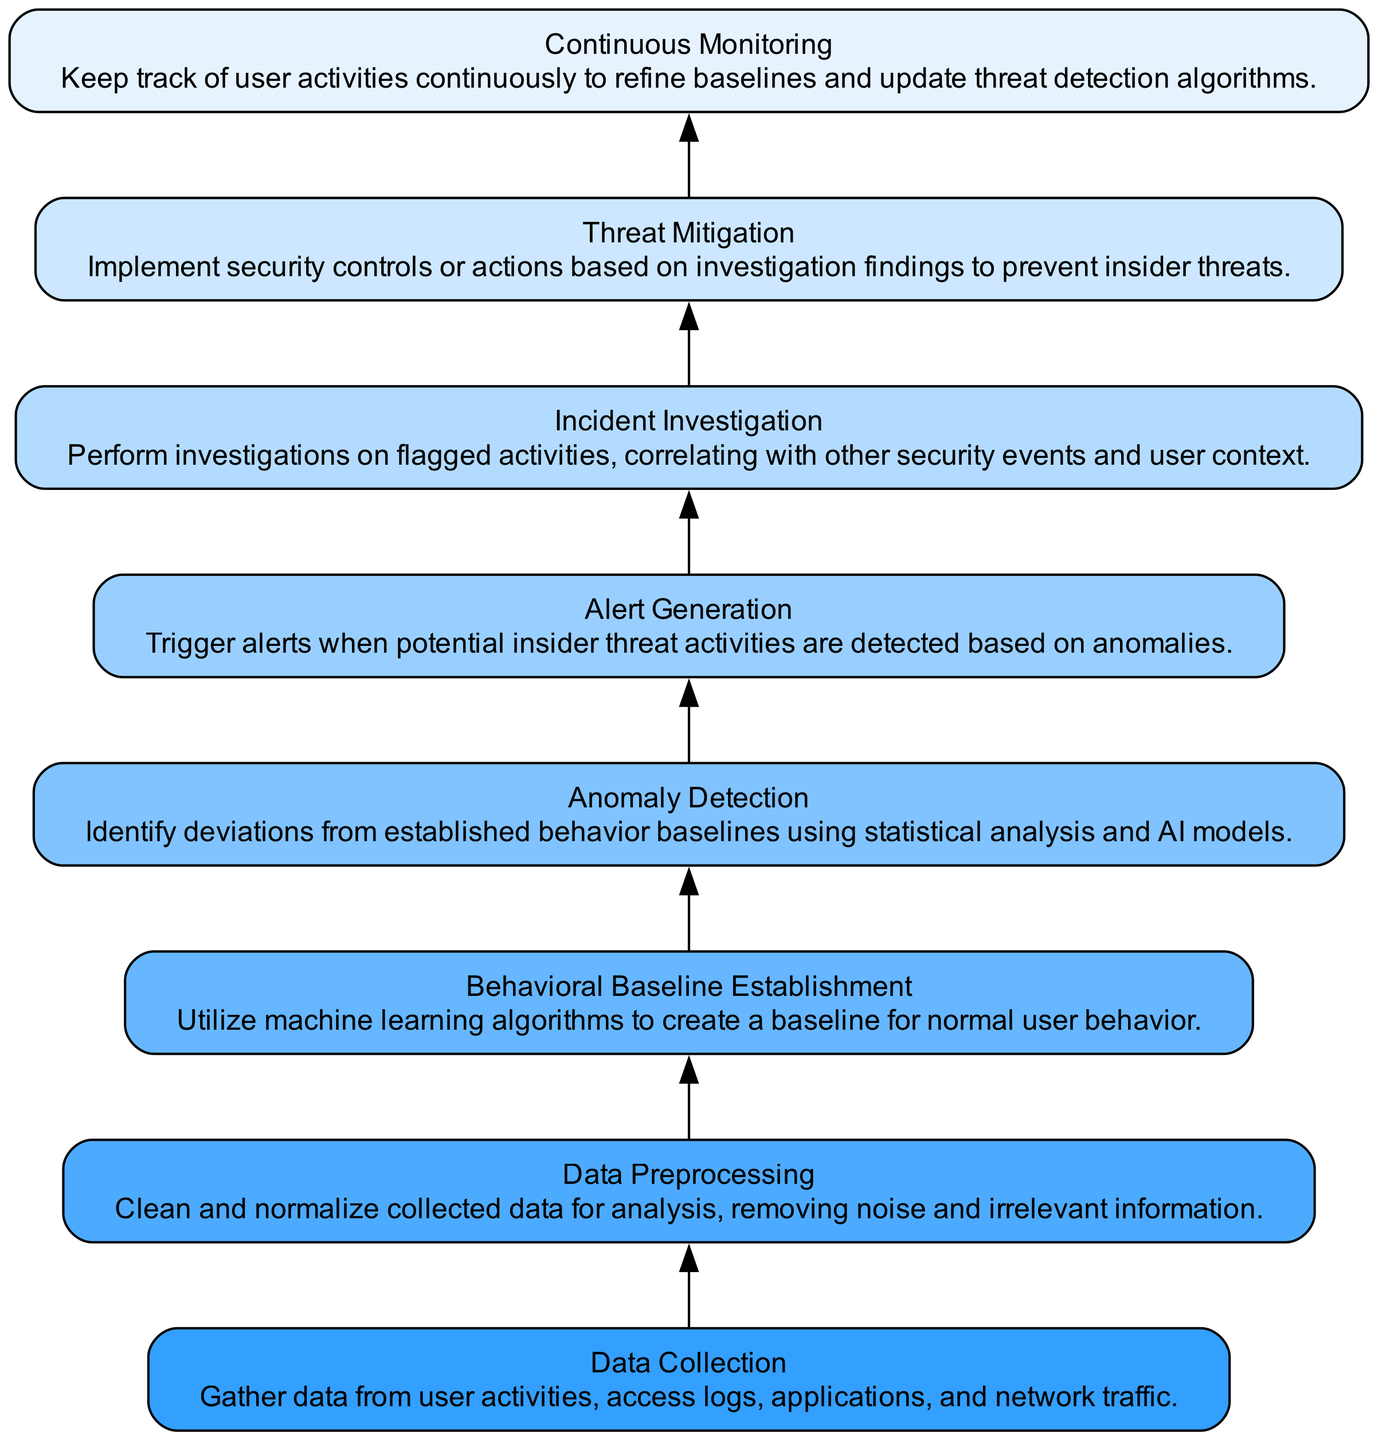What is the first step in the workflow? The first step in the workflow is "Data Collection," which is listed at the bottom of the flow chart. This indicates that the workflow begins with gathering data from user activities.
Answer: Data Collection How many total steps are in the workflow? The workflow consists of eight distinct steps, each represented as nodes in the diagram.
Answer: Eight Which step follows "Incident Investigation"? "Threat Mitigation" follows "Incident Investigation" in the sequence of the workflow. This is derived from the flow direction indicated by edges connecting the nodes.
Answer: Threat Mitigation What is the main purpose of "Anomaly Detection"? The main purpose of "Anomaly Detection" is to identify deviations from established behavior baselines. This is stated explicitly in the description of that node.
Answer: Identify deviations What triggers the "Alert Generation"? "Alert Generation" is triggered when potential insider threat activities are detected based on anomalies identified in the previous step, "Anomaly Detection." This relationship shows a direct connection between them.
Answer: Potential insider threat activities What is the relationship between "Behavioral Baseline Establishment" and "Anomaly Detection"? "Behavioral Baseline Establishment" precedes "Anomaly Detection," as the anomaly detection process relies on the established baseline of normal user behavior created in the previous step.
Answer: Establishes a baseline Which step involves continuous tracking of user activities? "Continuous Monitoring" is the step that involves the ongoing tracking of user activities to refine baselines and update detection algorithms, as stated in its description.
Answer: Continuous Monitoring What action is taken based on "Incident Investigation"? Based on "Incident Investigation," the action taken is "Threat Mitigation," where security controls are implemented according to investigation findings. This flow indicates a direct consequence of the investigation.
Answer: Implement security controls 